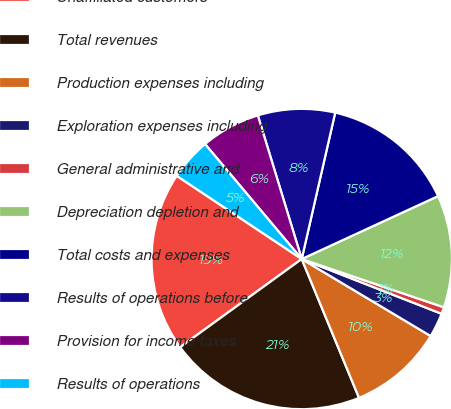Convert chart to OTSL. <chart><loc_0><loc_0><loc_500><loc_500><pie_chart><fcel>Unaffiliated customers<fcel>Total revenues<fcel>Production expenses including<fcel>Exploration expenses including<fcel>General administrative and<fcel>Depreciation depletion and<fcel>Total costs and expenses<fcel>Results of operations before<fcel>Provision for income taxes<fcel>Results of operations<nl><fcel>19.34%<fcel>21.24%<fcel>10.2%<fcel>2.63%<fcel>0.73%<fcel>12.09%<fcel>14.54%<fcel>8.3%<fcel>6.41%<fcel>4.52%<nl></chart> 